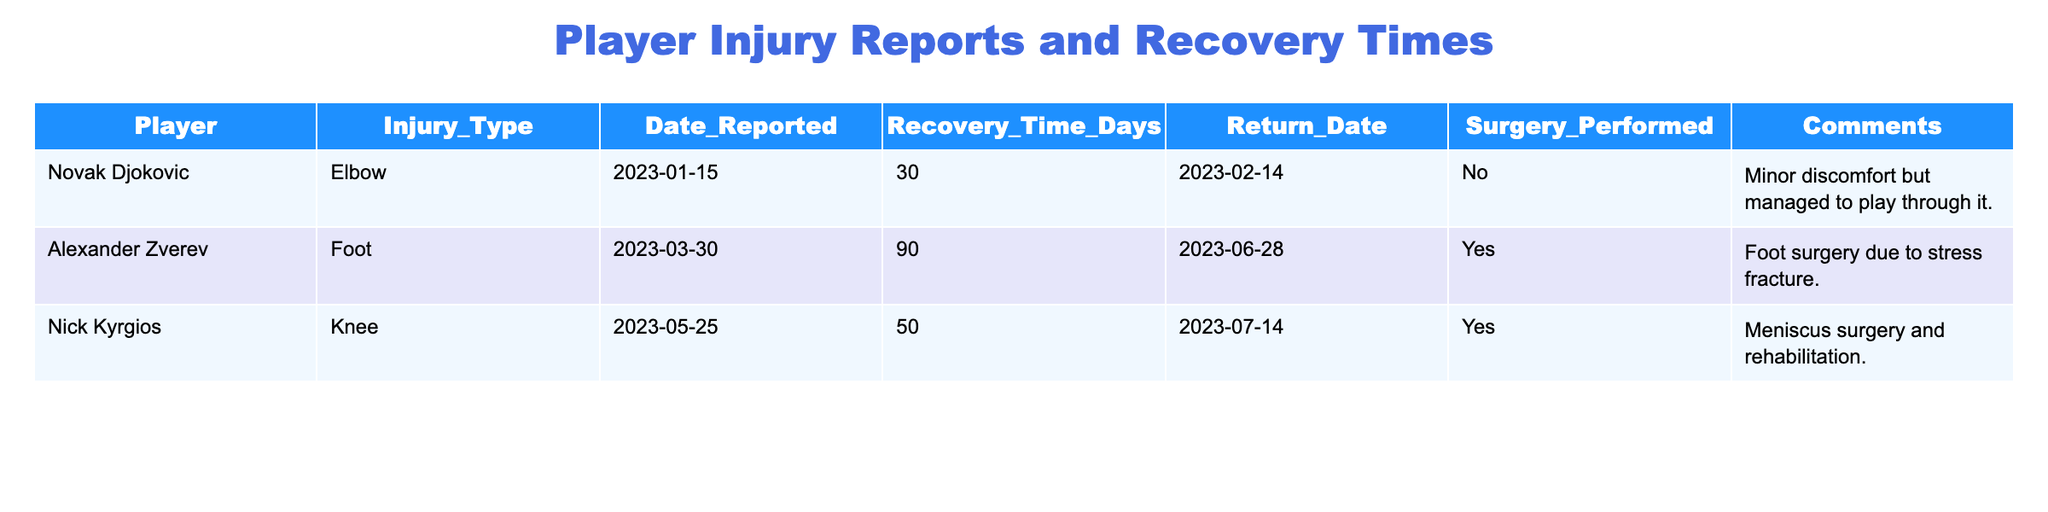What injury did Novak Djokovic sustain? The table states that Novak Djokovic had an elbow injury reported on January 15, 2023.
Answer: Elbow How many days was Nick Kyrgios's recovery time? The table indicates that Nick Kyrgios had a recovery time of 50 days due to his knee surgery.
Answer: 50 days Did Alexander Zverev undergo surgery for his injury? The table shows that Alexander Zverev had foot surgery due to a stress fracture, confirming that surgery was performed.
Answer: Yes Which player had the longest recovery time? By reviewing the recovery times listed for each player—30 days for Djokovic, 90 days for Zverev, and 50 days for Kyrgios—it is clear that Zverev had the longest recovery time.
Answer: Alexander Zverev What was the return date for Nick Kyrgios after his injury? The table provides a return date of July 14, 2023, for Nick Kyrgios after his recovery period of 50 days.
Answer: July 14, 2023 What is the average recovery time of the players listed? The recovery times are 30 days (Djokovic), 90 days (Zverev), and 50 days (Kyrgios). To find the average: (30 + 90 + 50) / 3 = 56.67 days.
Answer: 56.67 days What type of injury did Alexander Zverev have? The table specifies that Alexander Zverev suffered from a foot injury.
Answer: Foot Which player had no surgery performed for their injury? Novak Djokovic did not have surgery, as indicated in the comments column, while Zverev and Kyrgios both had surgeries.
Answer: Novak Djokovic Calculate the difference in recovery time between Djokovic and Zverev. Djokovic had a recovery time of 30 days, while Zverev had 90 days. The difference is 90 - 30 = 60 days.
Answer: 60 days Did any player comment on their injury experience? Yes, the comments section for all players contains remarks: Djokovic mentioned minor discomfort, Zverev noted surgery, and Kyrgios referred to meniscus surgery.
Answer: Yes 